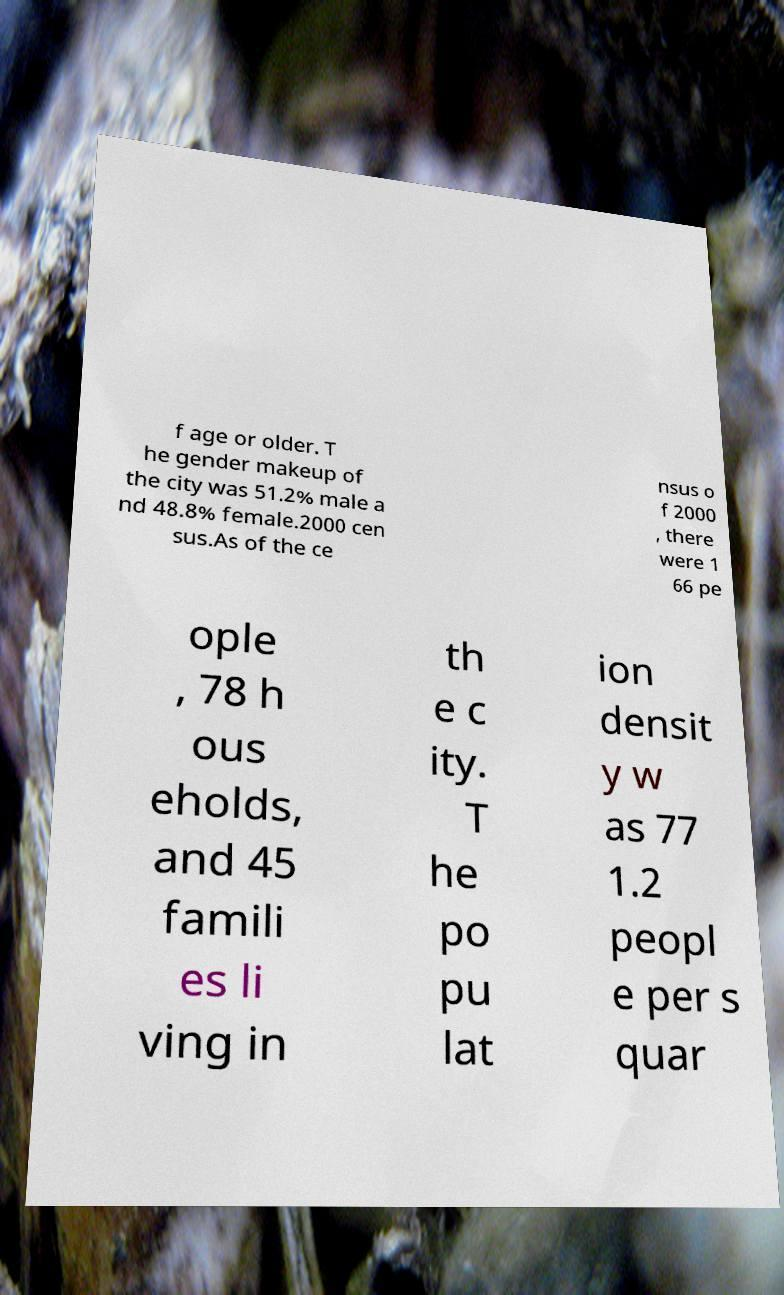Could you extract and type out the text from this image? f age or older. T he gender makeup of the city was 51.2% male a nd 48.8% female.2000 cen sus.As of the ce nsus o f 2000 , there were 1 66 pe ople , 78 h ous eholds, and 45 famili es li ving in th e c ity. T he po pu lat ion densit y w as 77 1.2 peopl e per s quar 